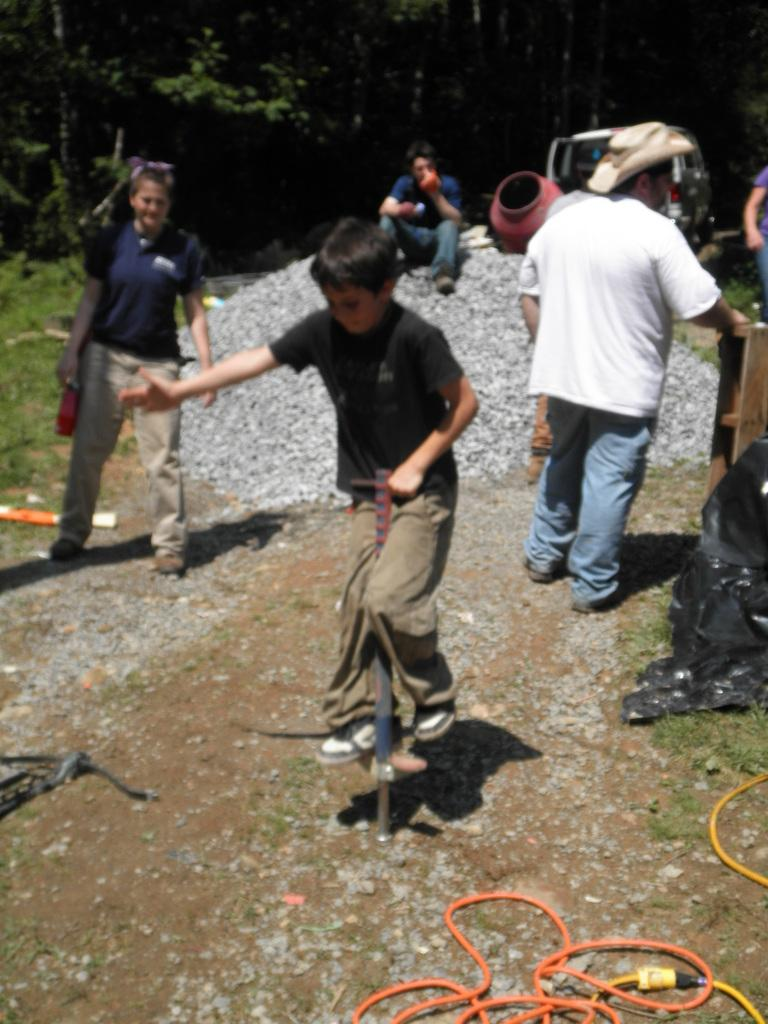How many people are in the image? There are people in the image, but the exact number is not specified. What is one person doing in the image? One person is standing on a pole. What is the person on the pole holding? The person on the pole is holding something. What can be seen in the background of the image? Trees, small stones, and vehicles are visible in the background. What is present on the ground in the image? There are objects on the ground. How does the person on the pole say good-bye to the other people in the image? There is no indication in the image that the person on the pole is saying good-bye to anyone. 